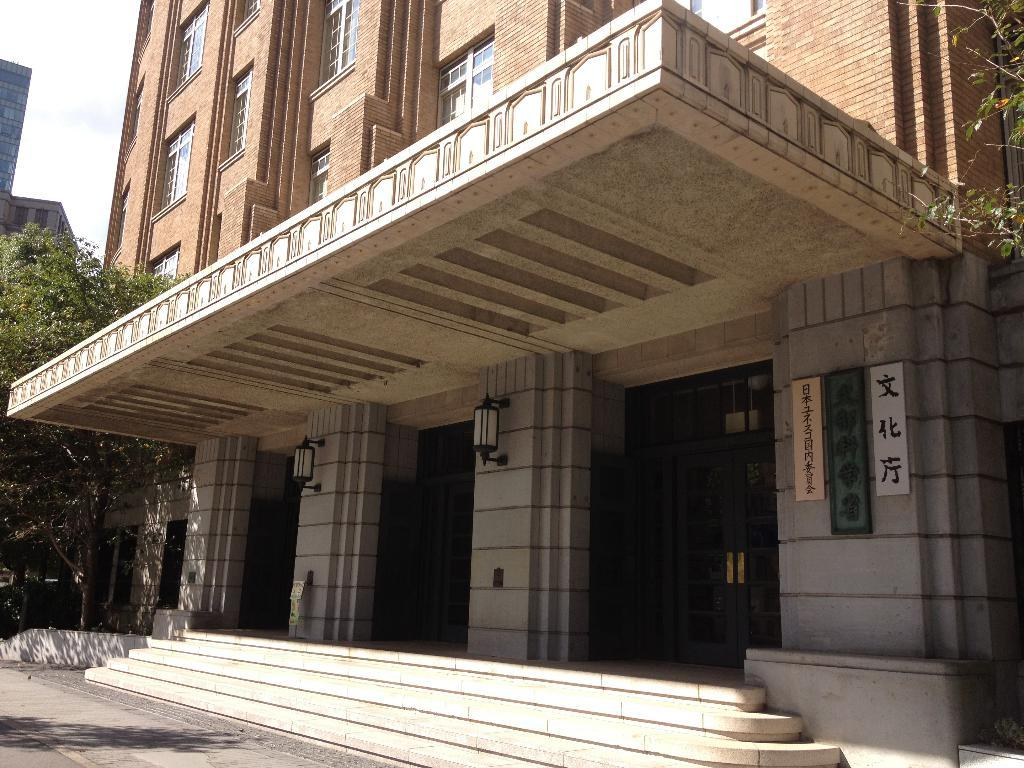What type of natural elements can be seen in the image? There are trees in the image. What type of man-made structures are present in the image? There are buildings in the image. What features can be observed on the buildings? Lights and banners are present on the buildings. What part of the sky is visible in the image? The sky is visible in the top left corner of the image. What type of trousers are the sheep wearing in the image? There are no sheep or trousers present in the image. How many times does the image need to be folded to fit into a pocket? The image cannot be folded to fit into a pocket, as it is a digital representation or a printed copy. 